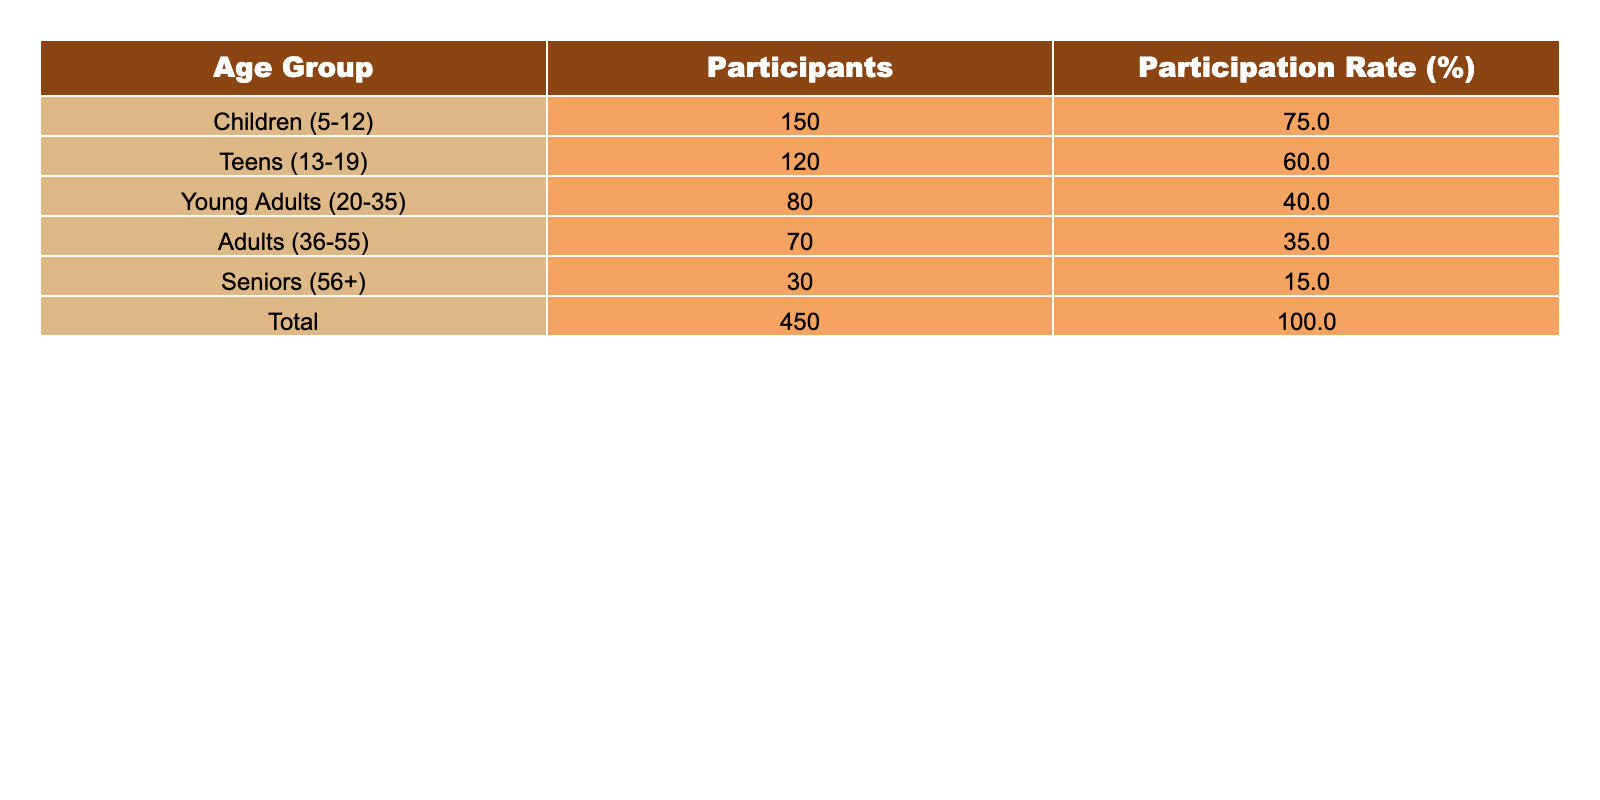What is the total number of participants in all age groups? The total number of participants is provided in the table under the "Total" row, which indicates 450 participants across all age groups.
Answer: 450 Which age group has the highest participation rate? Looking at the participation rates listed in the table, "Children (5-12)" has the highest participation rate of 75%.
Answer: Children (5-12) How many seniors participated in the workshops? The table shows that there were 30 participants in the "Seniors (56+)" age group.
Answer: 30 What is the average participation rate for all age groups? To find the average participation rate, we add all the individual participation rates: 75% + 60% + 40% + 35% + 15% = 225%. We then divide by the number of age groups (5): 225% / 5 = 45%.
Answer: 45% Did more than half of the teens participate in the workshops? The participation rate for the "Teens (13-19)" age group is 60%, which is indeed more than half (50%).
Answer: Yes What percentage of participants are adults (36-55) compared to the total? The number of adult participants is 70. To find the percentage: (70 / 450) * 100 = 15.56%. Thus, adults make up about 15.56% of total participants.
Answer: 15.56% What is the difference in participation rates between seniors and young adults? The participation rate for seniors is 15% and for young adults is 40%. The difference is calculated as 40% - 15% = 25%.
Answer: 25% If we combine the numbers for children and teens, what percentage of the total participants does this represent? Combining children (150) and teens (120) gives 270 participants. The percentage of total participants: (270 / 450) * 100 = 60%.
Answer: 60% Are there more participants in the children and teens categories combined than in the seniors and adults combined? The combined total of children and teens is 150 + 120 = 270. The combined total of seniors and adults is 30 + 70 = 100. Since 270 is greater than 100, the answer is yes.
Answer: Yes What is the ratio of young adults to seniors in terms of participation? There are 80 young adults and 30 seniors. The ratio of young adults to seniors is 80:30, which simplifies to 8:3.
Answer: 8:3 